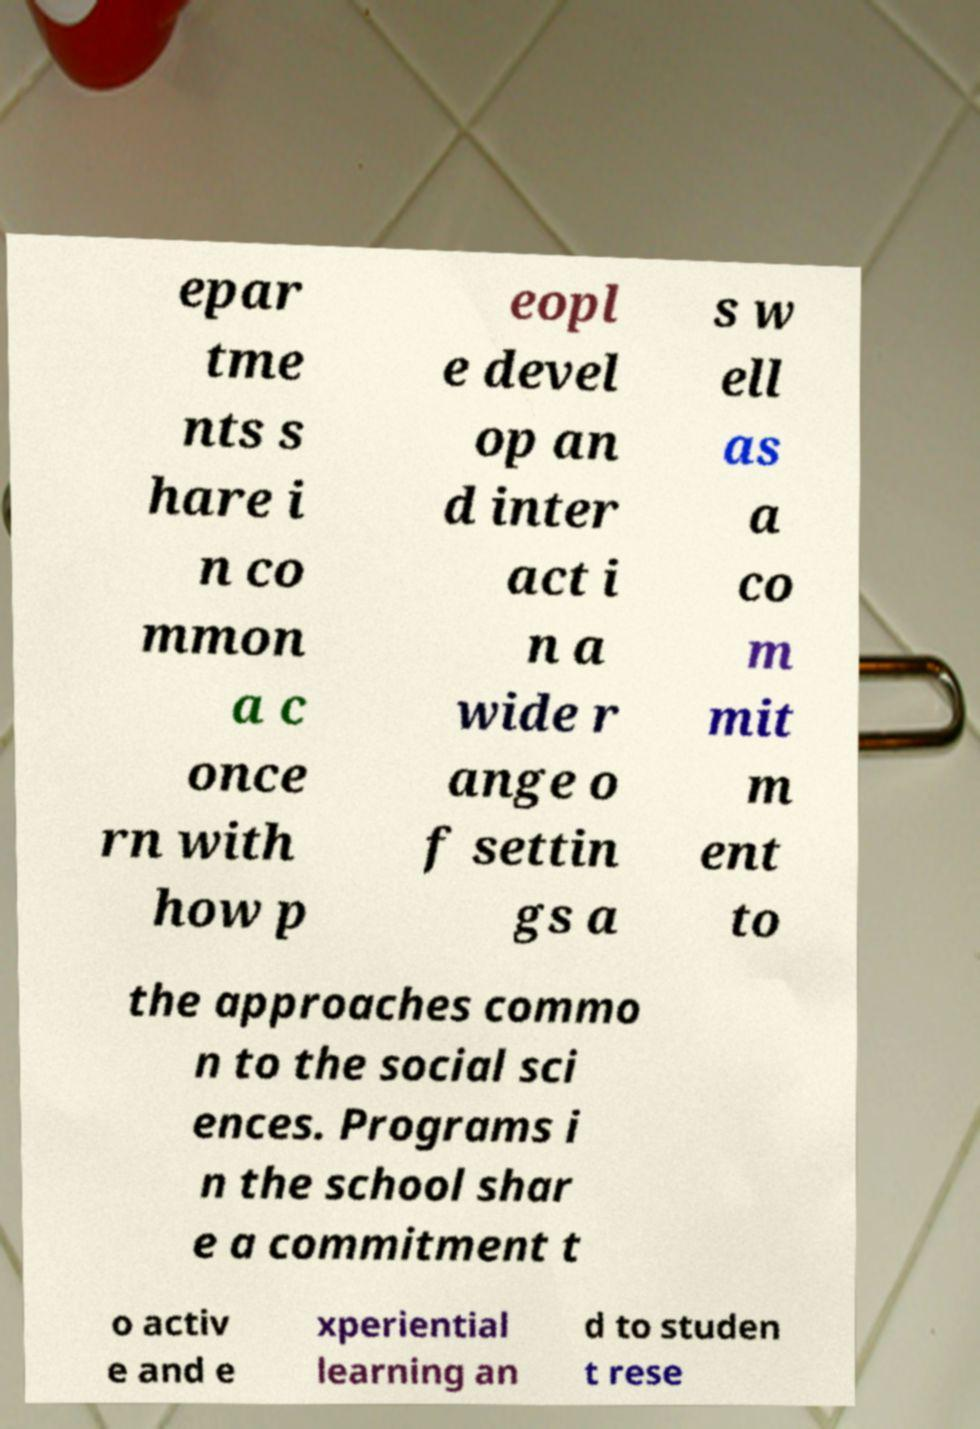Please read and relay the text visible in this image. What does it say? epar tme nts s hare i n co mmon a c once rn with how p eopl e devel op an d inter act i n a wide r ange o f settin gs a s w ell as a co m mit m ent to the approaches commo n to the social sci ences. Programs i n the school shar e a commitment t o activ e and e xperiential learning an d to studen t rese 